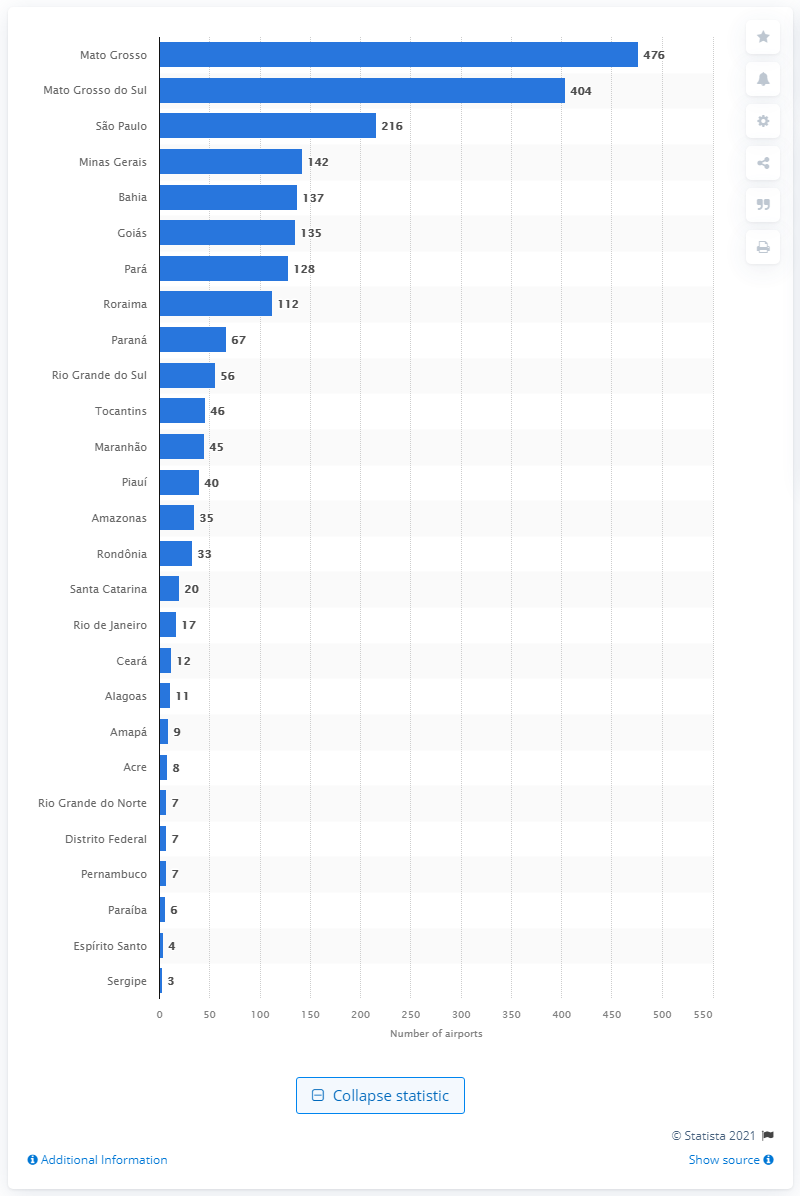Identify some key points in this picture. Mato Grosso is the Brazilian state with the highest number of private airports for civil aviation. As of October 15, 2019, there were 476 airports in the state of Mato Grosso. According to the most recent data available as of October 15, 2019, there were 216 private civil airports in the state of São Paulo. 